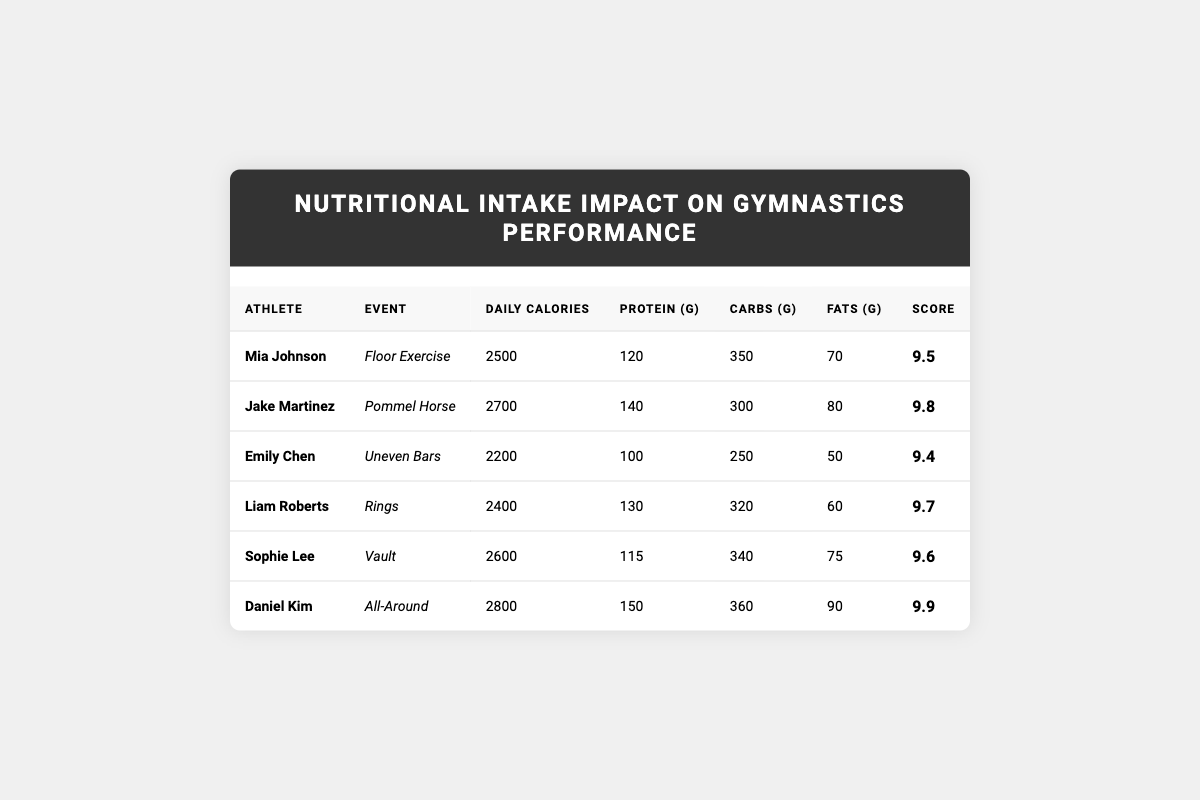What is the daily calorie intake of Daniel Kim? The table lists Daniel Kim's daily calorie intake under the "Daily Calories" column, which states that he consumes 2800 calories.
Answer: 2800 Which athlete has the highest score and what is it? The highest score is found in the last column. Looking through the scores, Daniel Kim has the highest score of 9.9.
Answer: 9.9 What is the total amount of protein intake for Mia Johnson and Emily Chen combined? Mia Johnson has a protein intake of 120 grams and Emily Chen has 100 grams. Adding these two values together gives 120 + 100 = 220 grams.
Answer: 220 Does Sophie Lee have a higher score than Liam Roberts? By comparing the scores in the table, Sophie Lee has a score of 9.6 while Liam Roberts has a score of 9.7. Therefore, Sophie Lee does not have a higher score than Liam Roberts.
Answer: No What is the average daily calorie intake of the athletes listed? The daily calorie intakes are 2500, 2700, 2200, 2400, 2600, and 2800. The sum is 2500 + 2700 + 2200 + 2400 + 2600 + 2800 = 15300. To find the average, divide by the number of athletes (6): 15300 / 6 = 2550.
Answer: 2550 Which event has the lowest protein intake among the listed athletes? Examining the protein intake column, Emily Chen has the lowest intake at 100 grams for the Uneven Bars event.
Answer: Uneven Bars Is the total fat intake of Jake Martinez greater than that of Liam Roberts? Jake Martinez has a fat intake of 80 grams and Liam Roberts has 60 grams. Since 80 is greater than 60, Jake Martinez has a higher fat intake than Liam Roberts.
Answer: Yes What is the difference in score between Daniel Kim and Mia Johnson? Daniel Kim has a score of 9.9 while Mia Johnson has a score of 9.5. The difference is calculated as 9.9 - 9.5 = 0.4.
Answer: 0.4 Which athlete has the highest carbohydrate intake? By analyzing the carbohydrate intake values, Daniel Kim has the highest intake of 360 grams for the All-Around event.
Answer: Daniel Kim What is the average score of all athletes listed? The scores are 9.5, 9.8, 9.4, 9.7, 9.6, and 9.9. The sum is 9.5 + 9.8 + 9.4 + 9.7 + 9.6 + 9.9 = 58.9. The average score is 58.9 / 6 = 9.8167, which rounds to approximately 9.82.
Answer: 9.82 